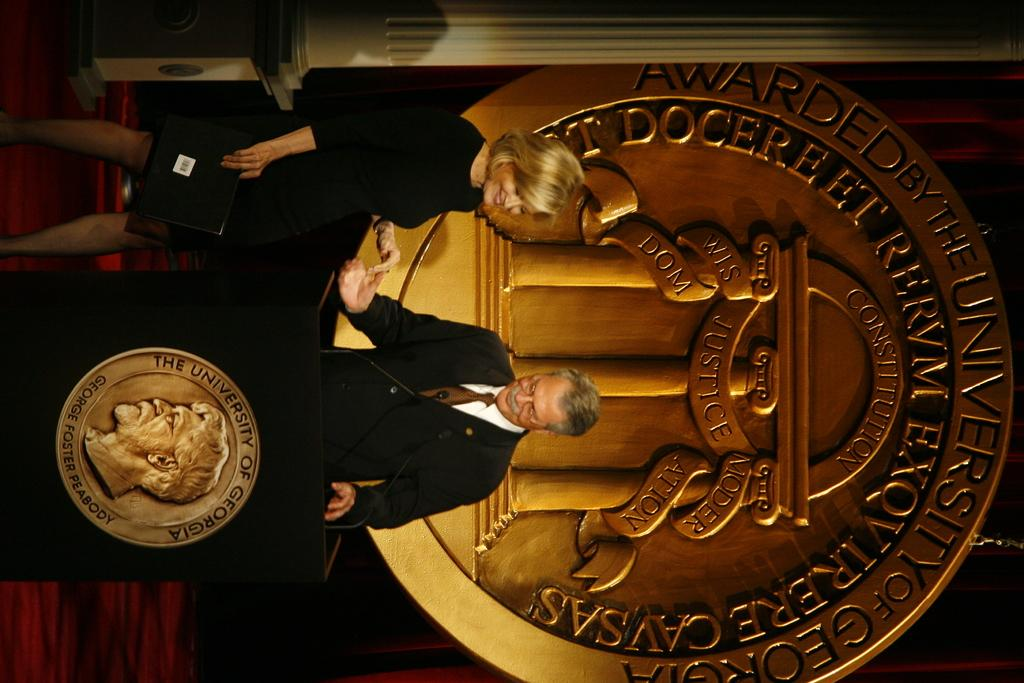Who can be seen near the podium on the left side of the image? There is a woman and a man near a podium on the left side of the image. What is located in the center of the image? There is an emblem on the wall in the center of the image. Can you describe the architectural feature at the top of the image? There is a pillar at the top of the image. What type of bread is being served to the girl in the image? There is no girl or bread present in the image. How does the dog interact with the emblem on the wall in the image? There is no dog present in the image, so it cannot interact with the emblem. 